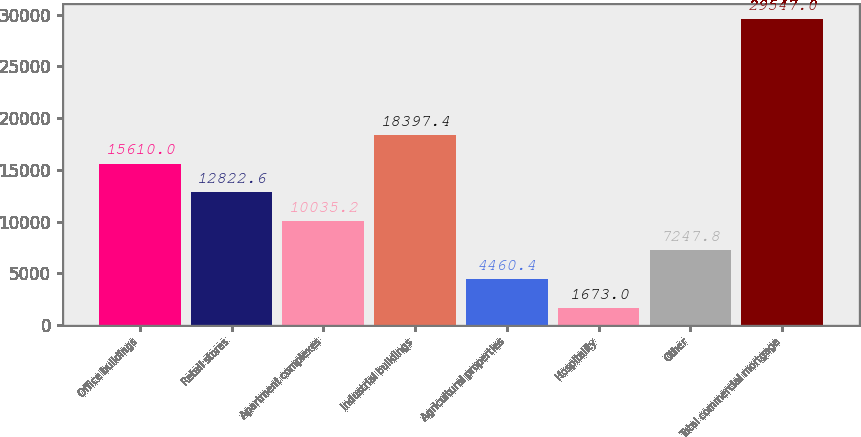<chart> <loc_0><loc_0><loc_500><loc_500><bar_chart><fcel>Office buildings<fcel>Retail stores<fcel>Apartment complexes<fcel>Industrial buildings<fcel>Agricultural properties<fcel>Hospitality<fcel>Other<fcel>Total commercial mortgage<nl><fcel>15610<fcel>12822.6<fcel>10035.2<fcel>18397.4<fcel>4460.4<fcel>1673<fcel>7247.8<fcel>29547<nl></chart> 